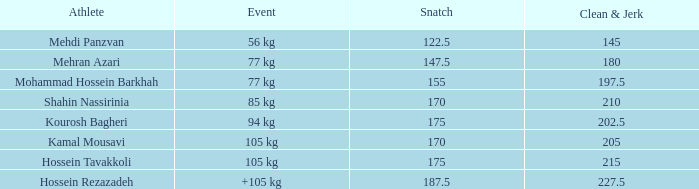What is the overall number that experienced a +105 kg event and a clean & jerk below 22 0.0. 